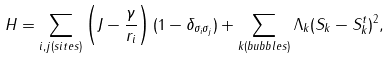<formula> <loc_0><loc_0><loc_500><loc_500>H = \sum _ { i , j ( s i t e s ) } \left ( J - \frac { \gamma } { r _ { i } } \right ) ( 1 - \delta _ { \sigma _ { i } \sigma _ { j } } ) + \sum _ { k ( b u b b l e s ) } \Lambda _ { k } ( S _ { k } - S _ { k } ^ { t } ) ^ { 2 } ,</formula> 